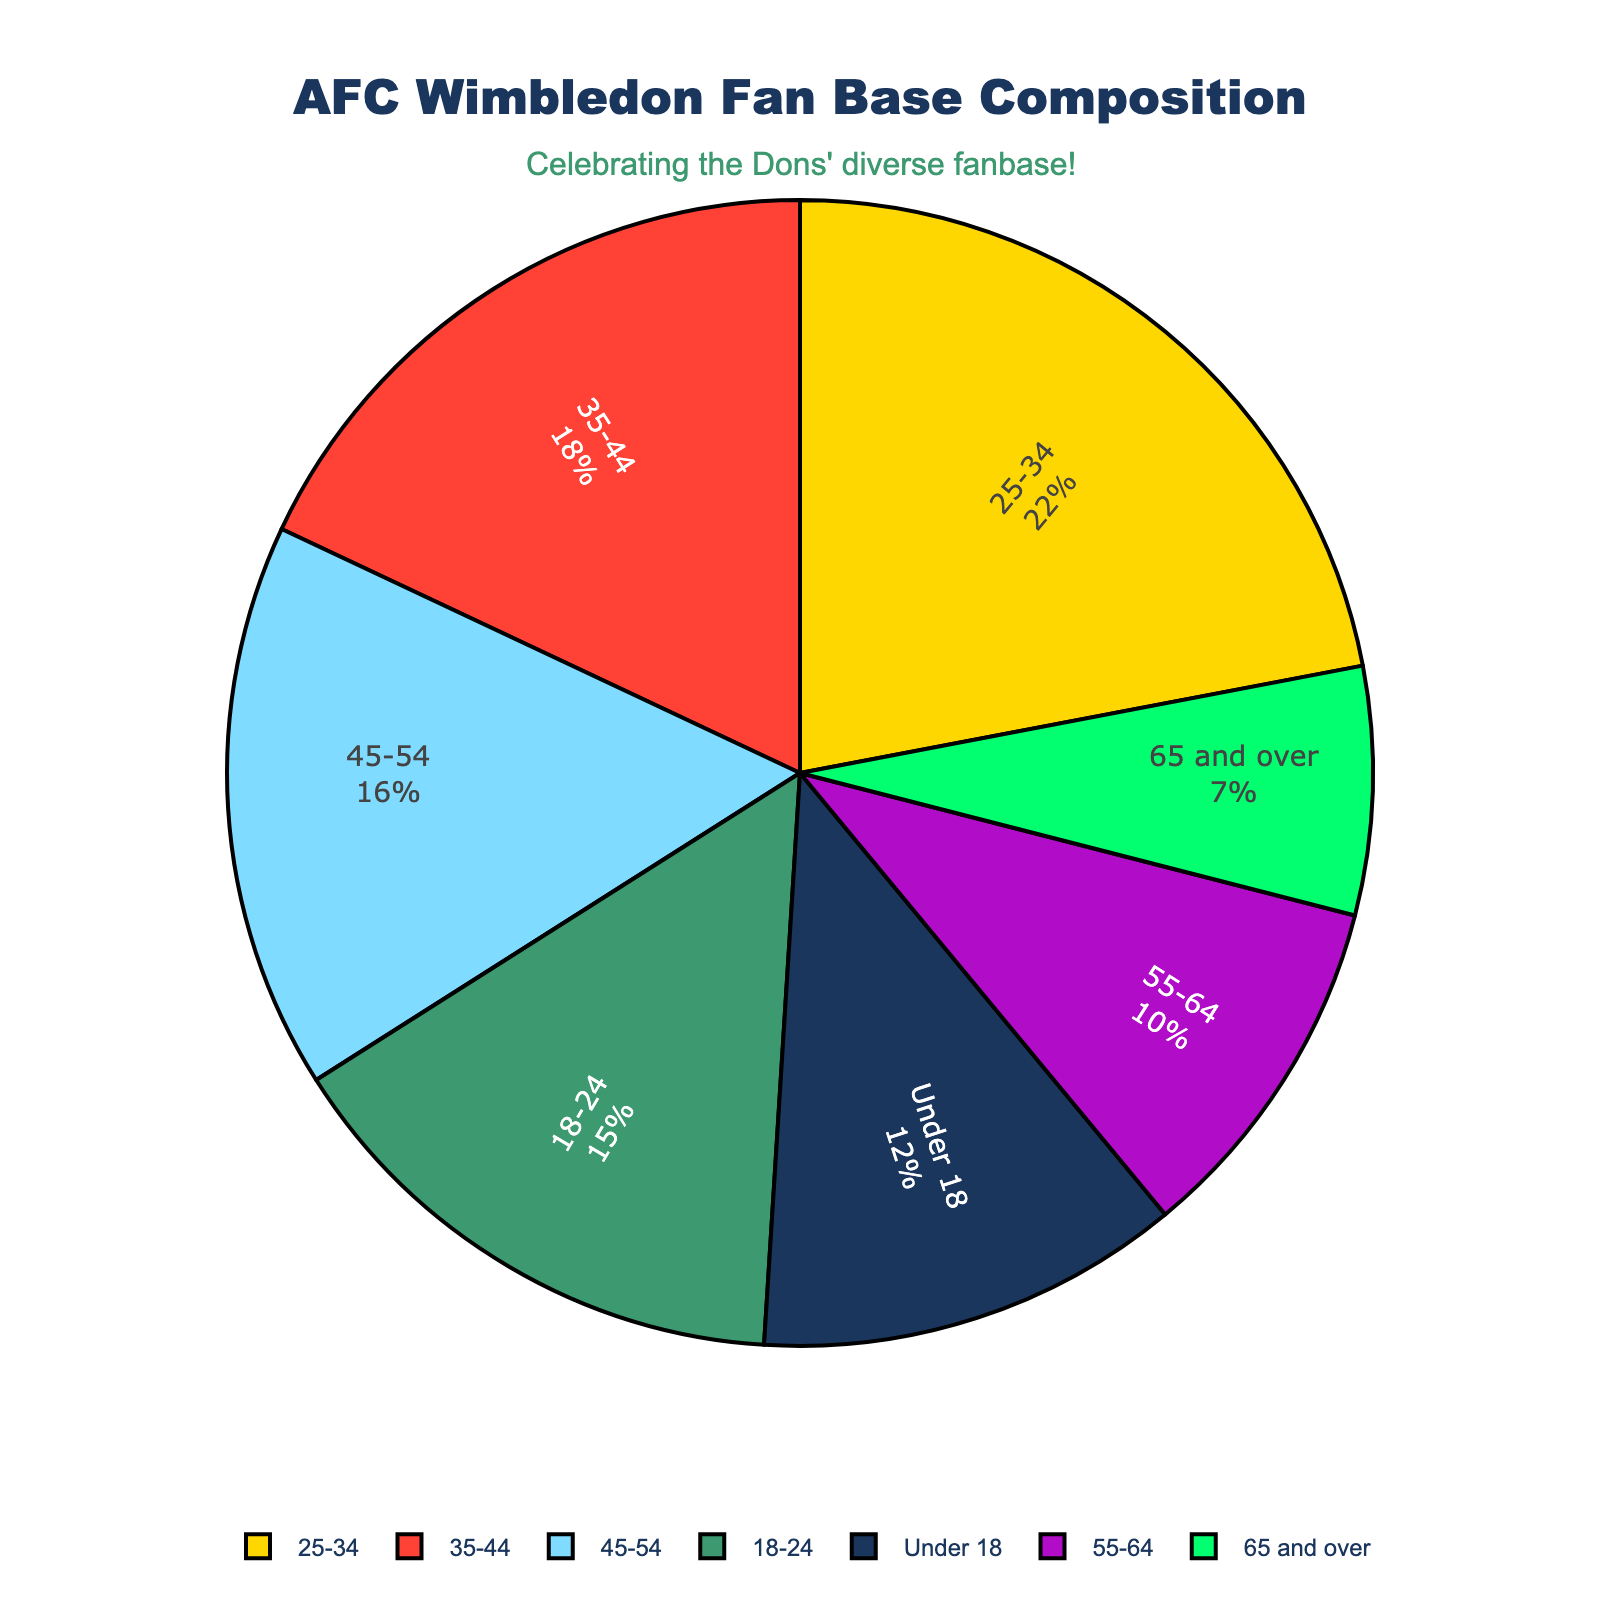What's the largest age group in the AFC Wimbledon fan base? The largest percentage on the pie chart corresponds to the 25-34 age group with 22%.
Answer: 25-34 Which age group has the smallest percentage of fans? By examining the pie chart, the smallest segment is for the 65 and over age group at 7%.
Answer: 65 and over How many age groups have a percentage of fans greater than 15%? There are three age groups with more than 15%: 18-24 (15%), 25-34 (22%), and 35-44 (18%).
Answer: Three Compare the fan base percentage of the 18-24 and 45-54 age groups. Which one is larger, and by how much? The 18-24 age group has 15%, and the 45-54 age group has 16%. The 45-54 age group is larger by 1%.
Answer: 45-54 by 1% What is the combined percentage of fans aged 55 and over? Adding the percentages for the 55-64 (10%) and 65 and over (7%) age groups: 10% + 7% = 17%.
Answer: 17% What color represents the age group with the largest fan base, and what is the percentage of that group? The 25-34 age group has the largest fan base (22%), represented by a prominent color on the chart. Given the color palette used, it should be gold or yellow.
Answer: Gold/Yellow, 22% What is the total percentage of fans under 35 years old? Sum the percentages for the Under 18 (12%), 18-24 (15%), and 25-34 (22%) age groups: 12% + 15% + 22% = 49%.
Answer: 49% 